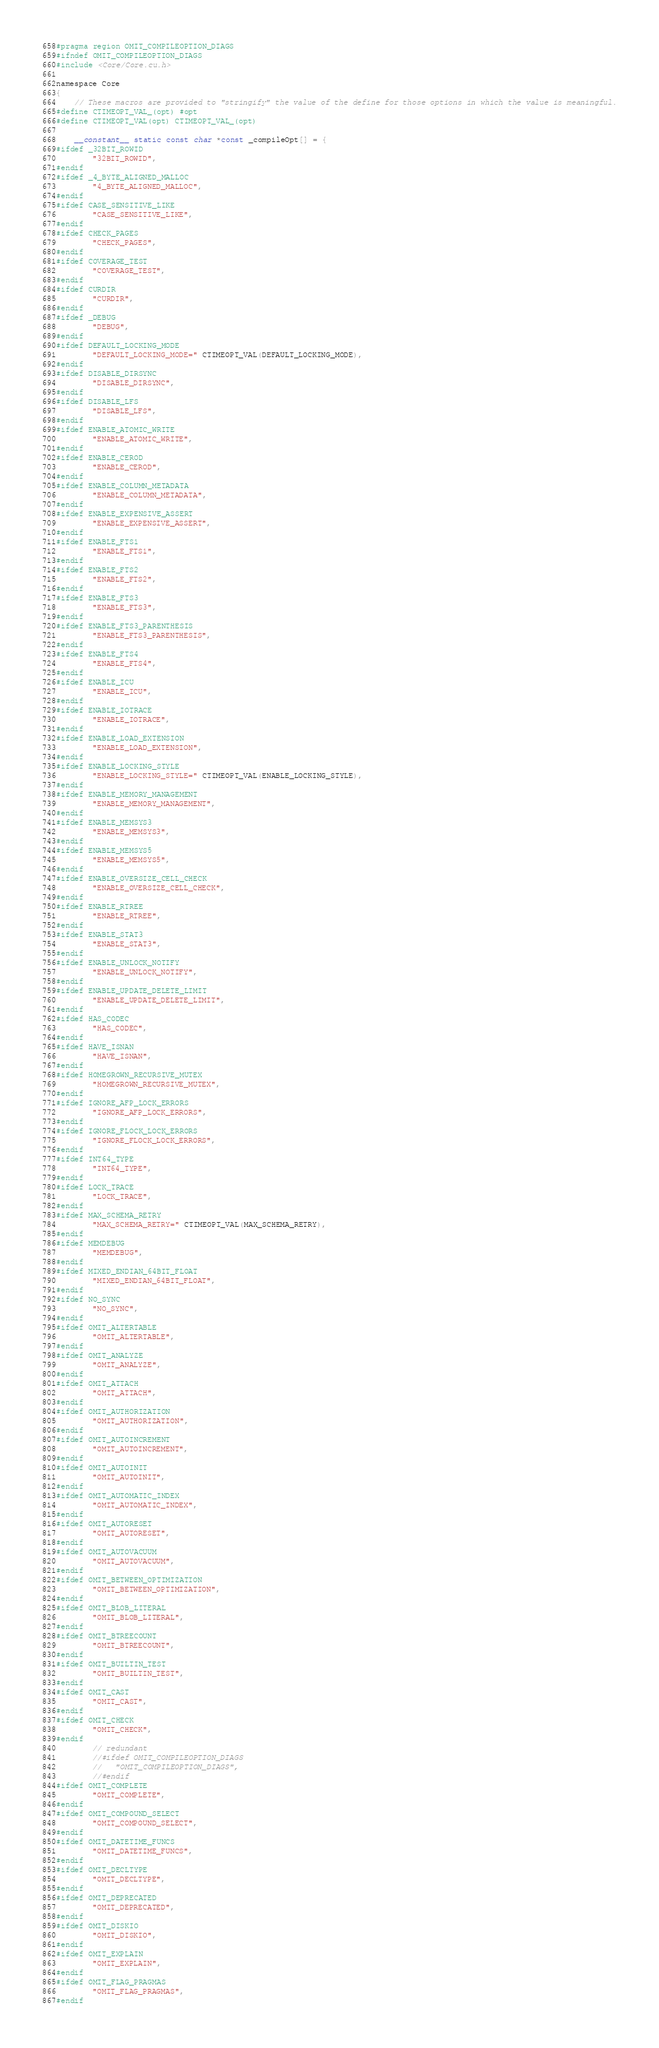<code> <loc_0><loc_0><loc_500><loc_500><_Cuda_>#pragma region OMIT_COMPILEOPTION_DIAGS
#ifndef OMIT_COMPILEOPTION_DIAGS
#include <Core/Core.cu.h>

namespace Core
{
	// These macros are provided to "stringify" the value of the define for those options in which the value is meaningful.
#define CTIMEOPT_VAL_(opt) #opt
#define CTIMEOPT_VAL(opt) CTIMEOPT_VAL_(opt)

	__constant__ static const char *const _compileOpt[] = {
#ifdef _32BIT_ROWID
		"32BIT_ROWID",
#endif
#ifdef _4_BYTE_ALIGNED_MALLOC
		"4_BYTE_ALIGNED_MALLOC",
#endif
#ifdef CASE_SENSITIVE_LIKE
		"CASE_SENSITIVE_LIKE",
#endif
#ifdef CHECK_PAGES
		"CHECK_PAGES",
#endif
#ifdef COVERAGE_TEST
		"COVERAGE_TEST",
#endif
#ifdef CURDIR
		"CURDIR",
#endif
#ifdef _DEBUG
		"DEBUG",
#endif
#ifdef DEFAULT_LOCKING_MODE
		"DEFAULT_LOCKING_MODE=" CTIMEOPT_VAL(DEFAULT_LOCKING_MODE),
#endif
#ifdef DISABLE_DIRSYNC
		"DISABLE_DIRSYNC",
#endif
#ifdef DISABLE_LFS
		"DISABLE_LFS",
#endif
#ifdef ENABLE_ATOMIC_WRITE
		"ENABLE_ATOMIC_WRITE",
#endif
#ifdef ENABLE_CEROD
		"ENABLE_CEROD",
#endif
#ifdef ENABLE_COLUMN_METADATA
		"ENABLE_COLUMN_METADATA",
#endif
#ifdef ENABLE_EXPENSIVE_ASSERT
		"ENABLE_EXPENSIVE_ASSERT",
#endif
#ifdef ENABLE_FTS1
		"ENABLE_FTS1",
#endif
#ifdef ENABLE_FTS2
		"ENABLE_FTS2",
#endif
#ifdef ENABLE_FTS3
		"ENABLE_FTS3",
#endif
#ifdef ENABLE_FTS3_PARENTHESIS
		"ENABLE_FTS3_PARENTHESIS",
#endif
#ifdef ENABLE_FTS4
		"ENABLE_FTS4",
#endif
#ifdef ENABLE_ICU
		"ENABLE_ICU",
#endif
#ifdef ENABLE_IOTRACE
		"ENABLE_IOTRACE",
#endif
#ifdef ENABLE_LOAD_EXTENSION
		"ENABLE_LOAD_EXTENSION",
#endif
#ifdef ENABLE_LOCKING_STYLE
		"ENABLE_LOCKING_STYLE=" CTIMEOPT_VAL(ENABLE_LOCKING_STYLE),
#endif
#ifdef ENABLE_MEMORY_MANAGEMENT
		"ENABLE_MEMORY_MANAGEMENT",
#endif
#ifdef ENABLE_MEMSYS3
		"ENABLE_MEMSYS3",
#endif
#ifdef ENABLE_MEMSYS5
		"ENABLE_MEMSYS5",
#endif
#ifdef ENABLE_OVERSIZE_CELL_CHECK
		"ENABLE_OVERSIZE_CELL_CHECK",
#endif
#ifdef ENABLE_RTREE
		"ENABLE_RTREE",
#endif
#ifdef ENABLE_STAT3
		"ENABLE_STAT3",
#endif
#ifdef ENABLE_UNLOCK_NOTIFY
		"ENABLE_UNLOCK_NOTIFY",
#endif
#ifdef ENABLE_UPDATE_DELETE_LIMIT
		"ENABLE_UPDATE_DELETE_LIMIT",
#endif
#ifdef HAS_CODEC
		"HAS_CODEC",
#endif
#ifdef HAVE_ISNAN
		"HAVE_ISNAN",
#endif
#ifdef HOMEGROWN_RECURSIVE_MUTEX
		"HOMEGROWN_RECURSIVE_MUTEX",
#endif
#ifdef IGNORE_AFP_LOCK_ERRORS
		"IGNORE_AFP_LOCK_ERRORS",
#endif
#ifdef IGNORE_FLOCK_LOCK_ERRORS
		"IGNORE_FLOCK_LOCK_ERRORS",
#endif
#ifdef INT64_TYPE
		"INT64_TYPE",
#endif
#ifdef LOCK_TRACE
		"LOCK_TRACE",
#endif
#ifdef MAX_SCHEMA_RETRY
		"MAX_SCHEMA_RETRY=" CTIMEOPT_VAL(MAX_SCHEMA_RETRY),
#endif
#ifdef MEMDEBUG
		"MEMDEBUG",
#endif
#ifdef MIXED_ENDIAN_64BIT_FLOAT
		"MIXED_ENDIAN_64BIT_FLOAT",
#endif
#ifdef NO_SYNC
		"NO_SYNC",
#endif
#ifdef OMIT_ALTERTABLE
		"OMIT_ALTERTABLE",
#endif
#ifdef OMIT_ANALYZE
		"OMIT_ANALYZE",
#endif
#ifdef OMIT_ATTACH
		"OMIT_ATTACH",
#endif
#ifdef OMIT_AUTHORIZATION
		"OMIT_AUTHORIZATION",
#endif
#ifdef OMIT_AUTOINCREMENT
		"OMIT_AUTOINCREMENT",
#endif
#ifdef OMIT_AUTOINIT
		"OMIT_AUTOINIT",
#endif
#ifdef OMIT_AUTOMATIC_INDEX
		"OMIT_AUTOMATIC_INDEX",
#endif
#ifdef OMIT_AUTORESET
		"OMIT_AUTORESET",
#endif
#ifdef OMIT_AUTOVACUUM
		"OMIT_AUTOVACUUM",
#endif
#ifdef OMIT_BETWEEN_OPTIMIZATION
		"OMIT_BETWEEN_OPTIMIZATION",
#endif
#ifdef OMIT_BLOB_LITERAL
		"OMIT_BLOB_LITERAL",
#endif
#ifdef OMIT_BTREECOUNT
		"OMIT_BTREECOUNT",
#endif
#ifdef OMIT_BUILTIN_TEST
		"OMIT_BUILTIN_TEST",
#endif
#ifdef OMIT_CAST
		"OMIT_CAST",
#endif
#ifdef OMIT_CHECK
		"OMIT_CHECK",
#endif
		// redundant
		//#ifdef OMIT_COMPILEOPTION_DIAGS
		//   "OMIT_COMPILEOPTION_DIAGS",
		//#endif
#ifdef OMIT_COMPLETE
		"OMIT_COMPLETE",
#endif
#ifdef OMIT_COMPOUND_SELECT
		"OMIT_COMPOUND_SELECT",
#endif
#ifdef OMIT_DATETIME_FUNCS
		"OMIT_DATETIME_FUNCS",
#endif
#ifdef OMIT_DECLTYPE
		"OMIT_DECLTYPE",
#endif
#ifdef OMIT_DEPRECATED
		"OMIT_DEPRECATED",
#endif
#ifdef OMIT_DISKIO
		"OMIT_DISKIO",
#endif
#ifdef OMIT_EXPLAIN
		"OMIT_EXPLAIN",
#endif
#ifdef OMIT_FLAG_PRAGMAS
		"OMIT_FLAG_PRAGMAS",
#endif</code> 